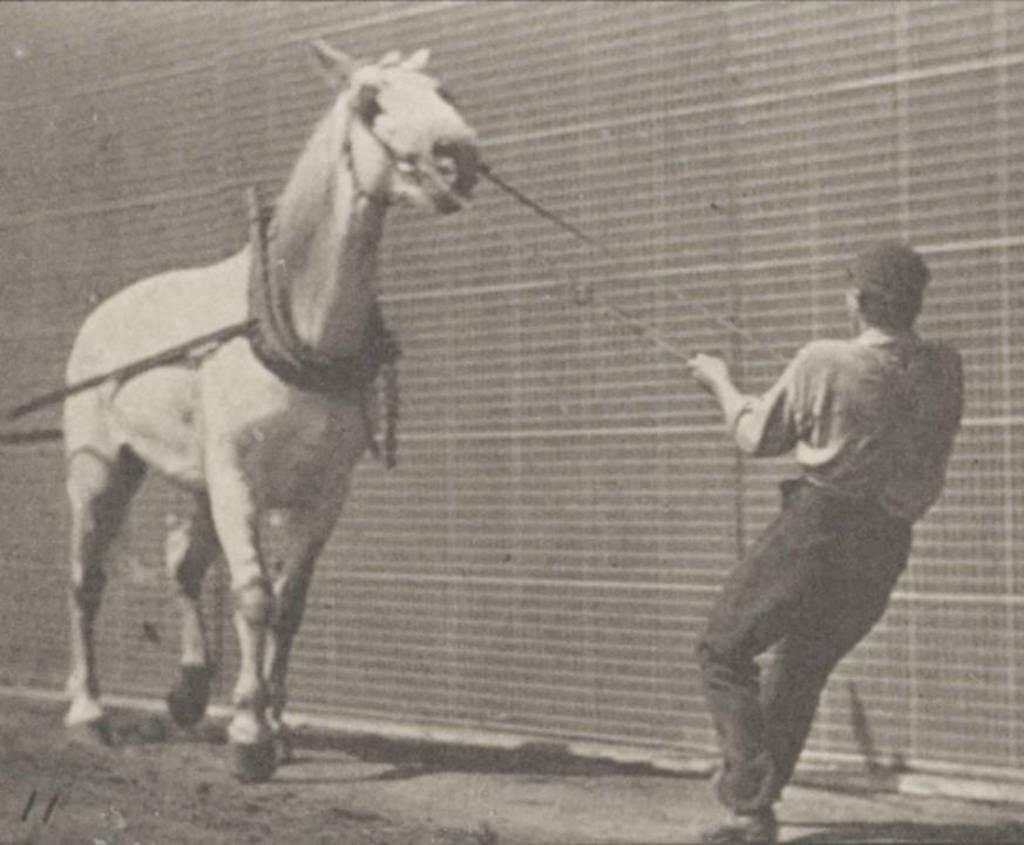What is the color scheme of the image? The image is black and white. What animal is present in the image? There is a horse in the image. Who is in the image with the horse? There is a man in the image. What is the man doing with the horse? The man is holding ropes and pulling the horse. What can be seen in the background of the image? There appears to be a wall in the image. What type of oatmeal is being served at the horse's birthday party in the image? There is no oatmeal or birthday party present in the image; it features a man pulling a horse with ropes in a black and white setting. 